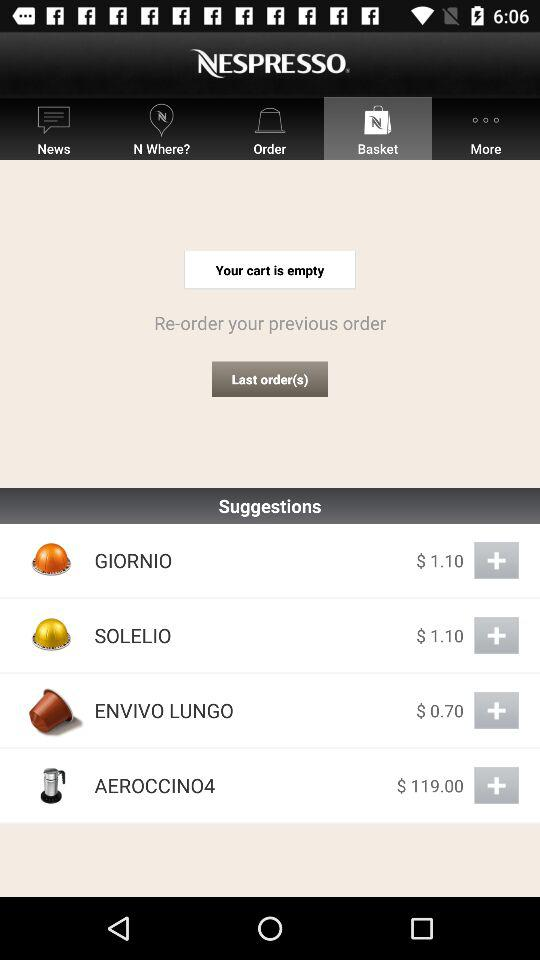What is the price of "SOLELIO"? The price of "SOLELIO" is $1.10. 